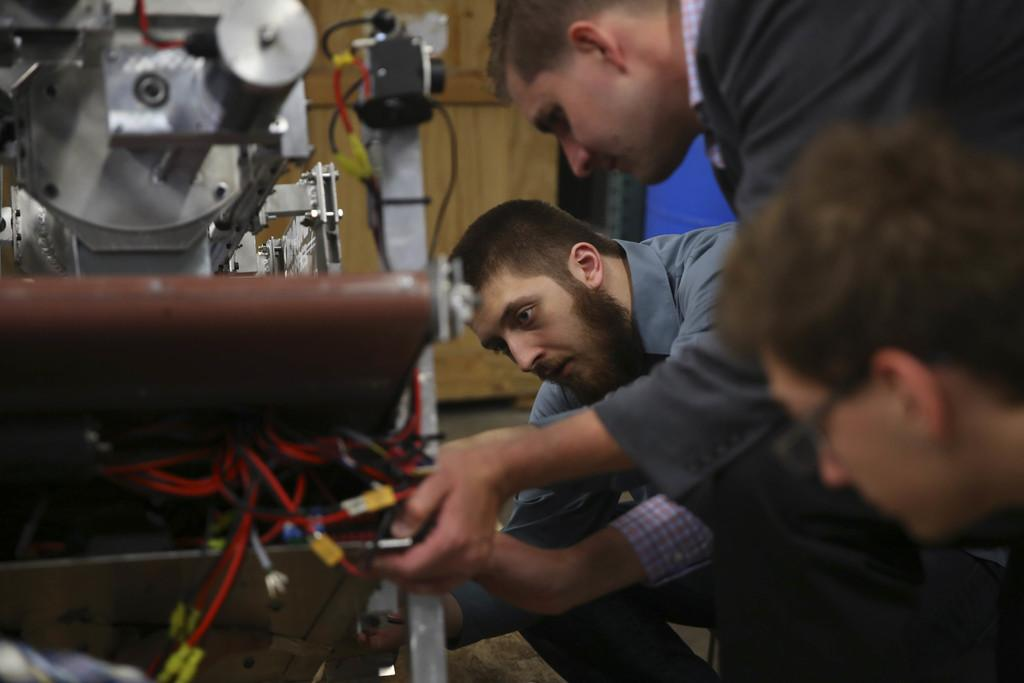Who or what can be seen in the image? There are people in the image. What else is present in the image besides the people? There is a machine and cables in the image. Where is the key used to operate the machine in the image? There is no key visible in the image, and it is not mentioned that the machine requires a key for operation. 